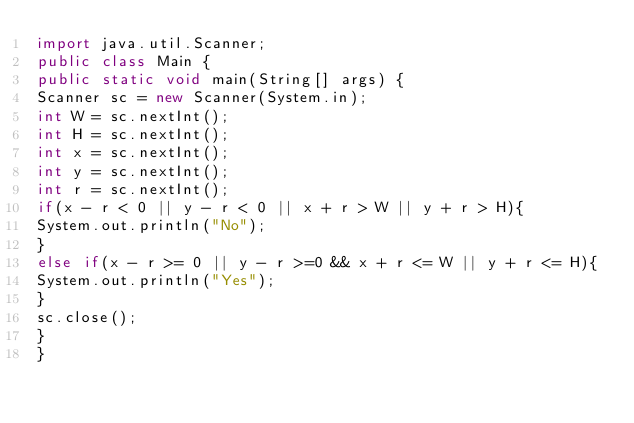Convert code to text. <code><loc_0><loc_0><loc_500><loc_500><_Java_>import java.util.Scanner;
public class Main {
public static void main(String[] args) {
Scanner sc = new Scanner(System.in);
int W = sc.nextInt();
int H = sc.nextInt();
int x = sc.nextInt();
int y = sc.nextInt();
int r = sc.nextInt();
if(x - r < 0 || y - r < 0 || x + r > W || y + r > H){
System.out.println("No");
}
else if(x - r >= 0 || y - r >=0 && x + r <= W || y + r <= H){
System.out.println("Yes");
}
sc.close();
}
}


</code> 